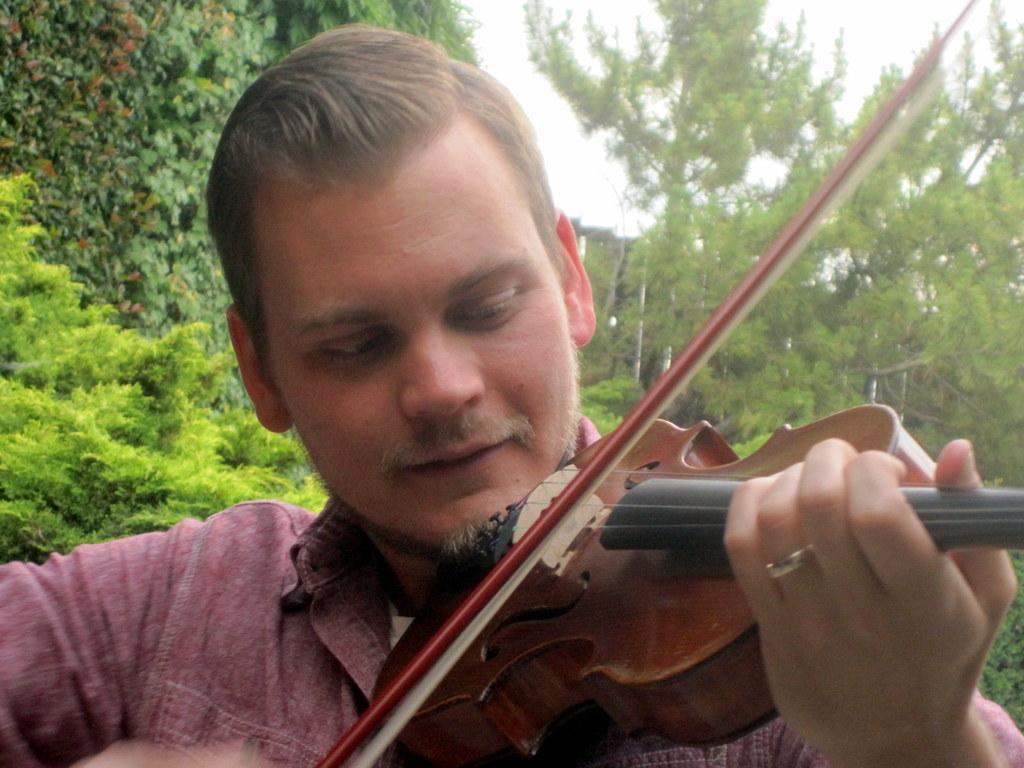What is the man in the image doing? The man is playing a violin. Can you describe the background of the image? There are trees visible in the background of the image. Where is the queen sitting in the image? There is no queen present in the image. What type of mountain can be seen in the background of the image? There are no mountains visible in the image; only trees are present in the background. 